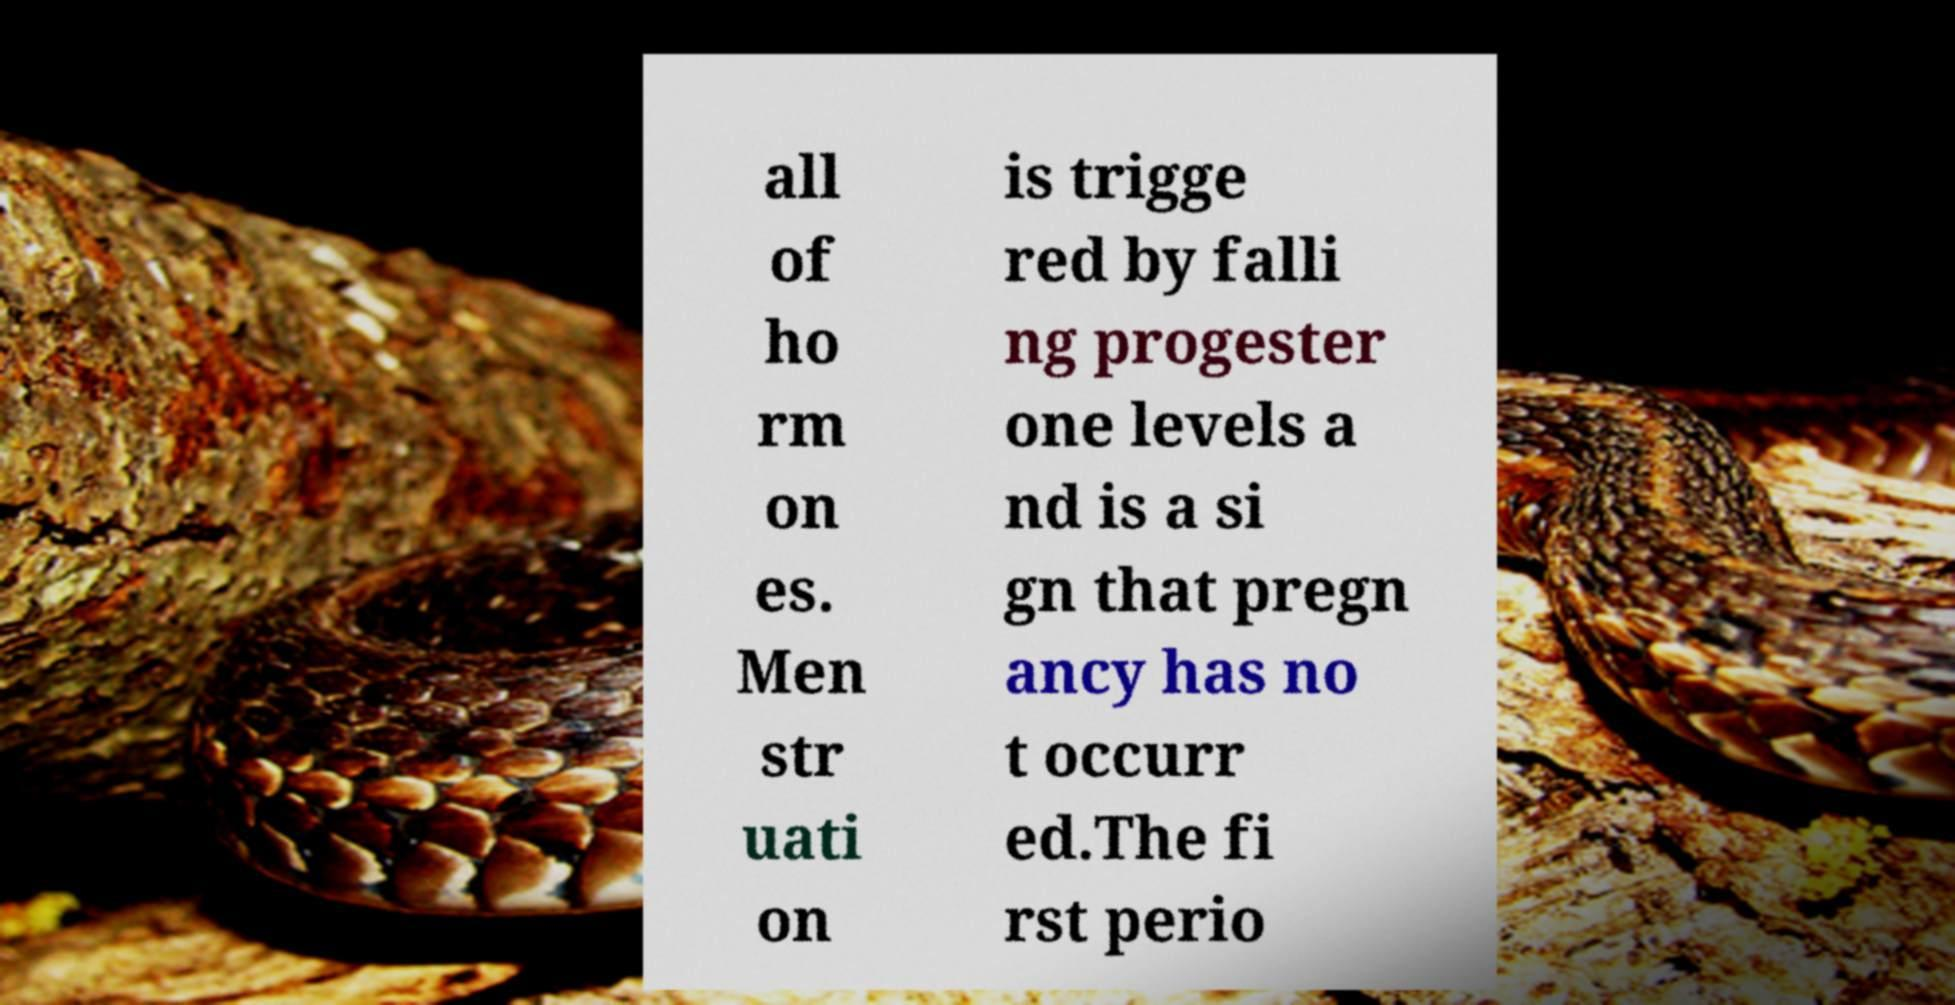Could you extract and type out the text from this image? all of ho rm on es. Men str uati on is trigge red by falli ng progester one levels a nd is a si gn that pregn ancy has no t occurr ed.The fi rst perio 